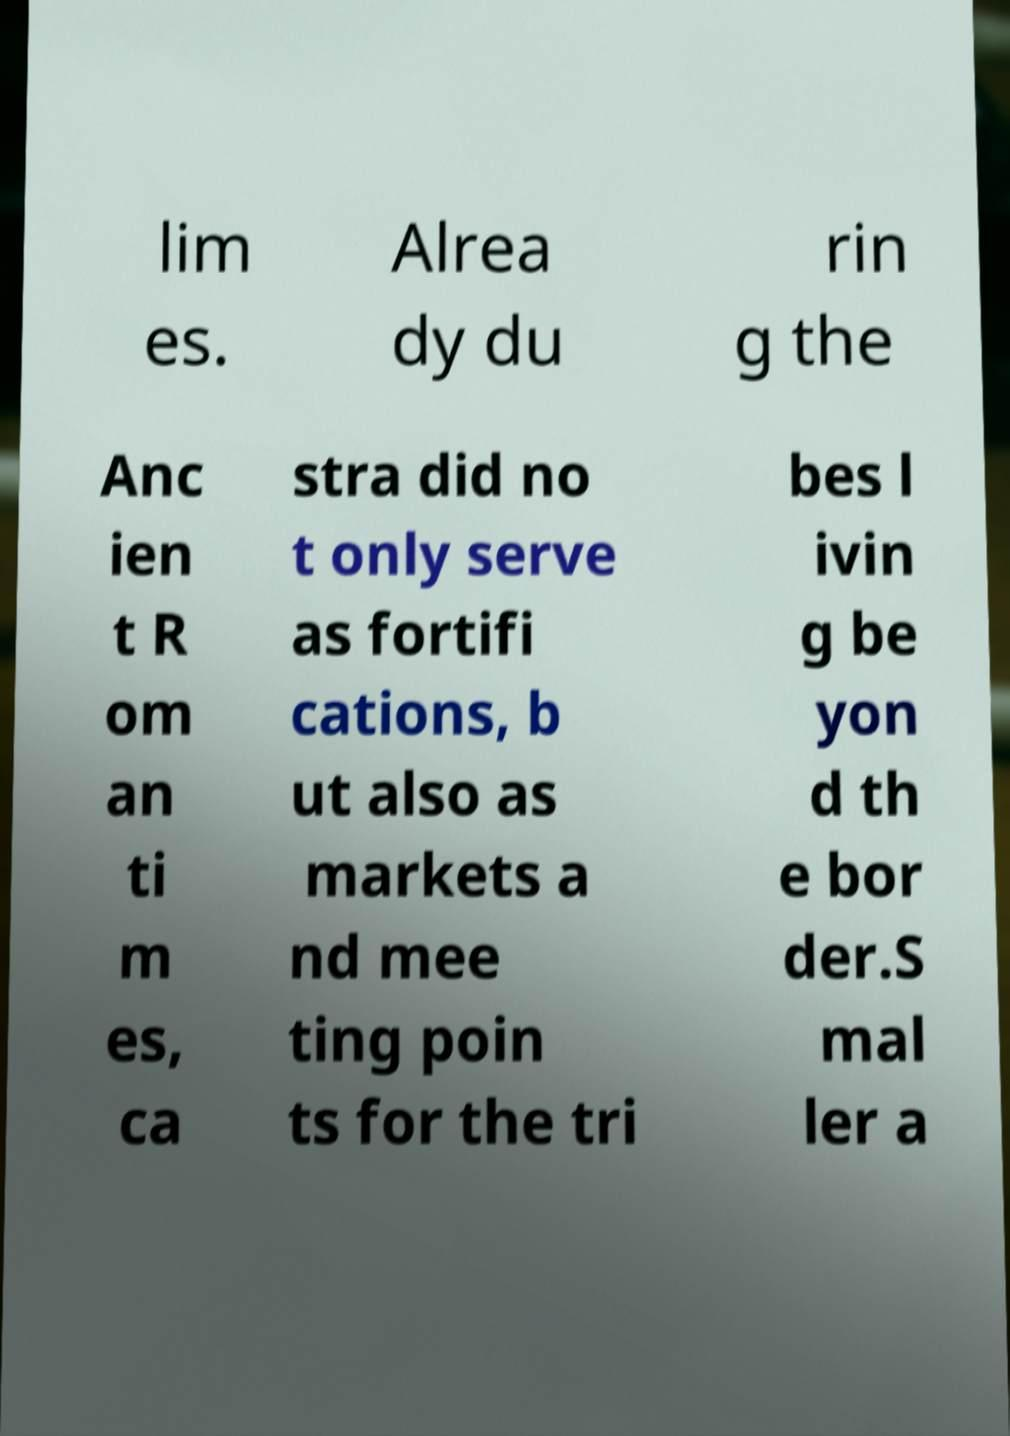I need the written content from this picture converted into text. Can you do that? lim es. Alrea dy du rin g the Anc ien t R om an ti m es, ca stra did no t only serve as fortifi cations, b ut also as markets a nd mee ting poin ts for the tri bes l ivin g be yon d th e bor der.S mal ler a 